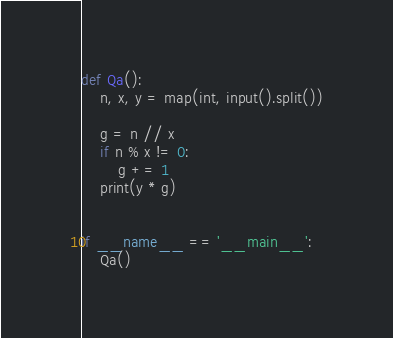<code> <loc_0><loc_0><loc_500><loc_500><_Python_>def Qa():
    n, x, y = map(int, input().split())

    g = n // x
    if n % x != 0:
        g += 1
    print(y * g)


if __name__ == '__main__':
    Qa()
</code> 